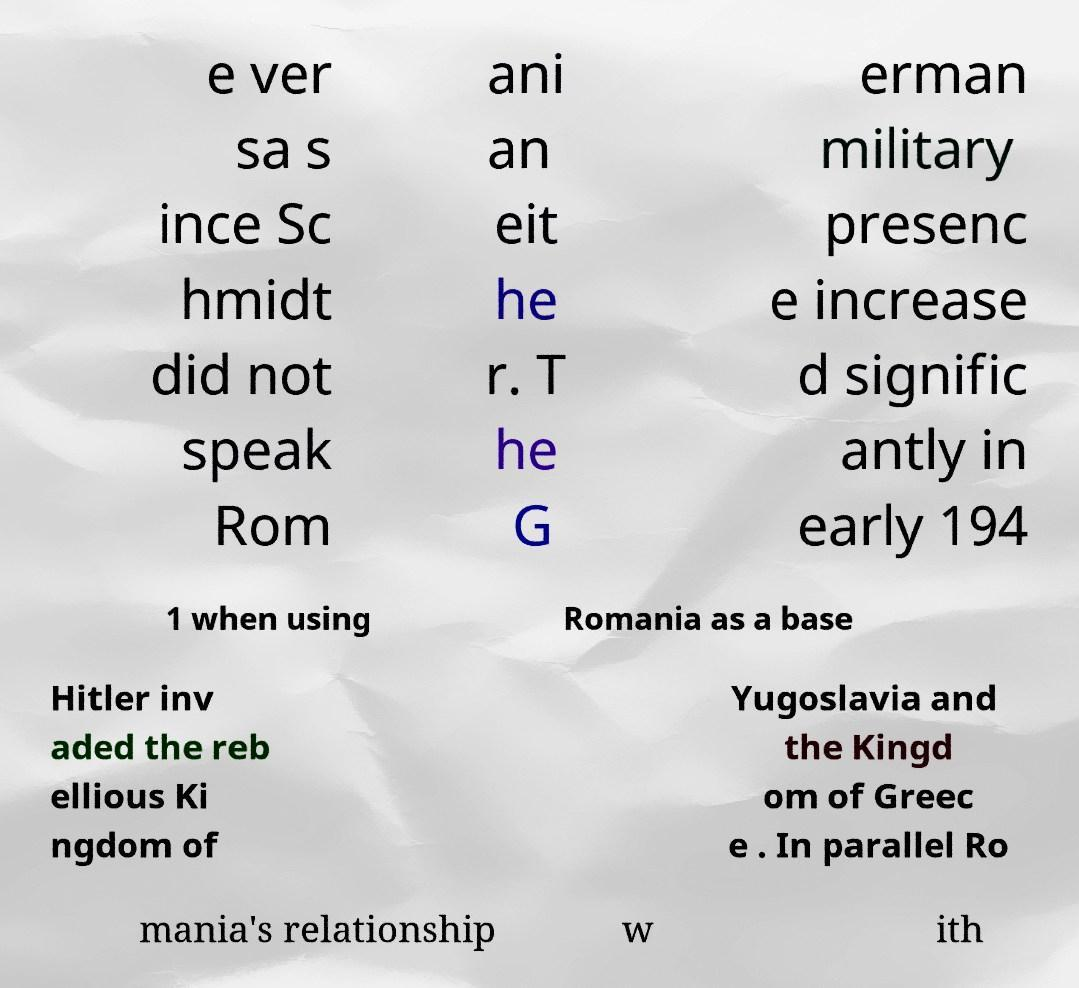Please identify and transcribe the text found in this image. e ver sa s ince Sc hmidt did not speak Rom ani an eit he r. T he G erman military presenc e increase d signific antly in early 194 1 when using Romania as a base Hitler inv aded the reb ellious Ki ngdom of Yugoslavia and the Kingd om of Greec e . In parallel Ro mania's relationship w ith 